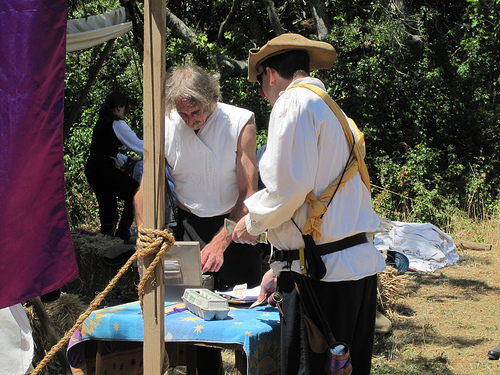<image>
Is the lady on the rock? Yes. Looking at the image, I can see the lady is positioned on top of the rock, with the rock providing support. Is there a hat on the man? No. The hat is not positioned on the man. They may be near each other, but the hat is not supported by or resting on top of the man. 